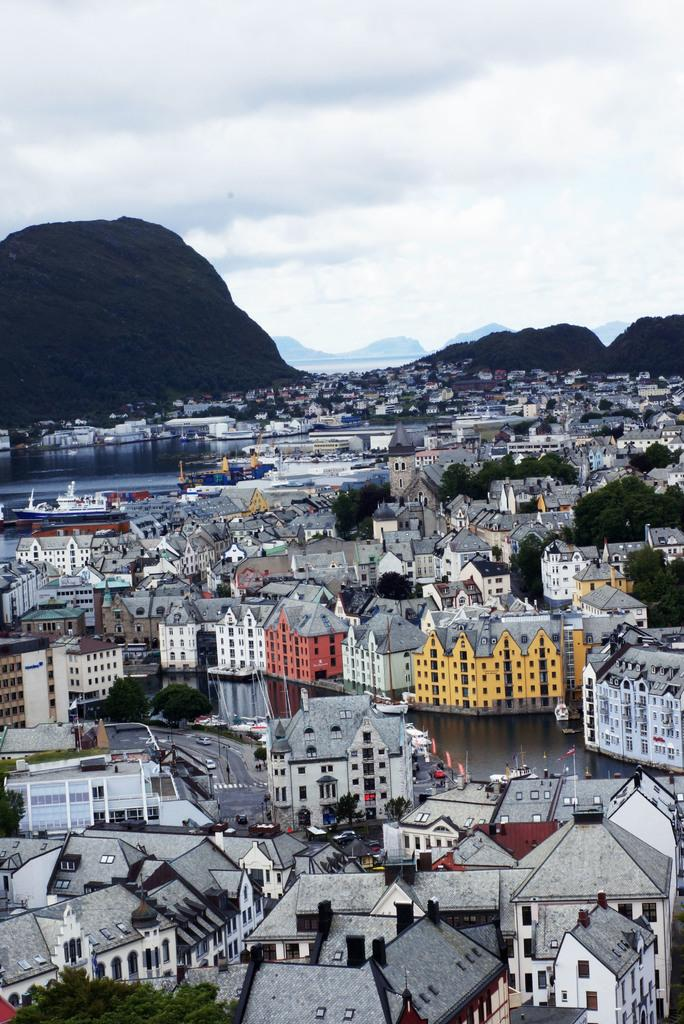What type of view is shown in the image? The image is an aerial view. What structures can be seen in the image? There are buildings in the image. What type of vegetation is present in the image? There are trees in the image. What type of transportation can be seen in the image? There are boats in the image. What type of natural feature is present in the image? There are hills in the image. What type of surface is visible in the image? There is water visible in the image. What is visible in the sky at the top of the image? There are clouds in the sky at the top of the image. What type of treatment is being administered to the trees in the image? There is no treatment being administered to the trees in the image; they are simply visible in the landscape. 